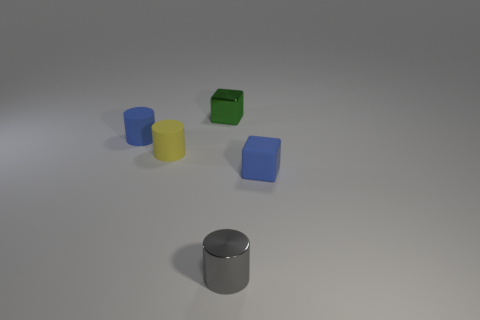Subtract all blue blocks. How many blocks are left? 1 Subtract all tiny blue cylinders. How many cylinders are left? 2 Subtract all cyan spheres. How many gray cylinders are left? 1 Add 5 yellow matte things. How many objects exist? 10 Subtract all cylinders. How many objects are left? 2 Subtract 1 cubes. How many cubes are left? 1 Subtract all green cylinders. Subtract all red spheres. How many cylinders are left? 3 Subtract all metal cylinders. Subtract all tiny metallic cylinders. How many objects are left? 3 Add 4 small rubber cubes. How many small rubber cubes are left? 5 Add 1 green rubber objects. How many green rubber objects exist? 1 